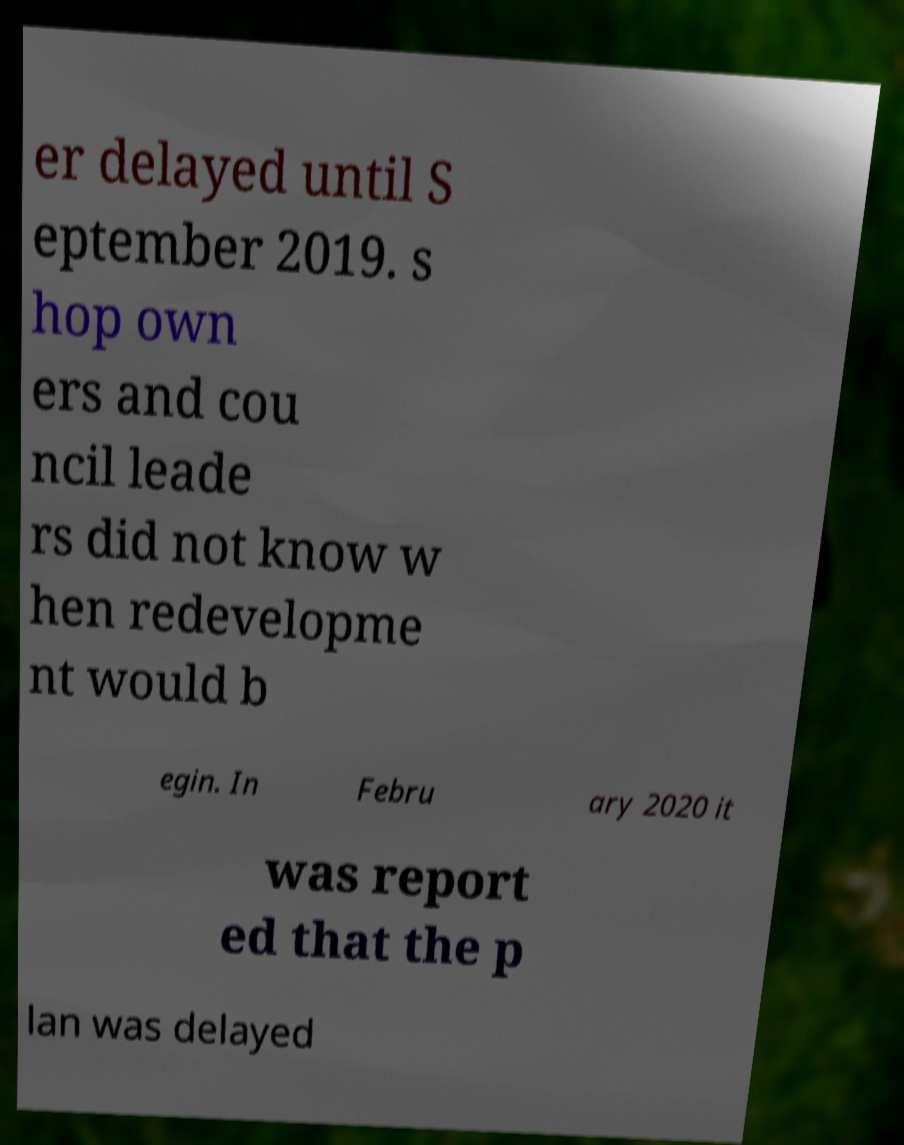Could you extract and type out the text from this image? er delayed until S eptember 2019. s hop own ers and cou ncil leade rs did not know w hen redevelopme nt would b egin. In Febru ary 2020 it was report ed that the p lan was delayed 